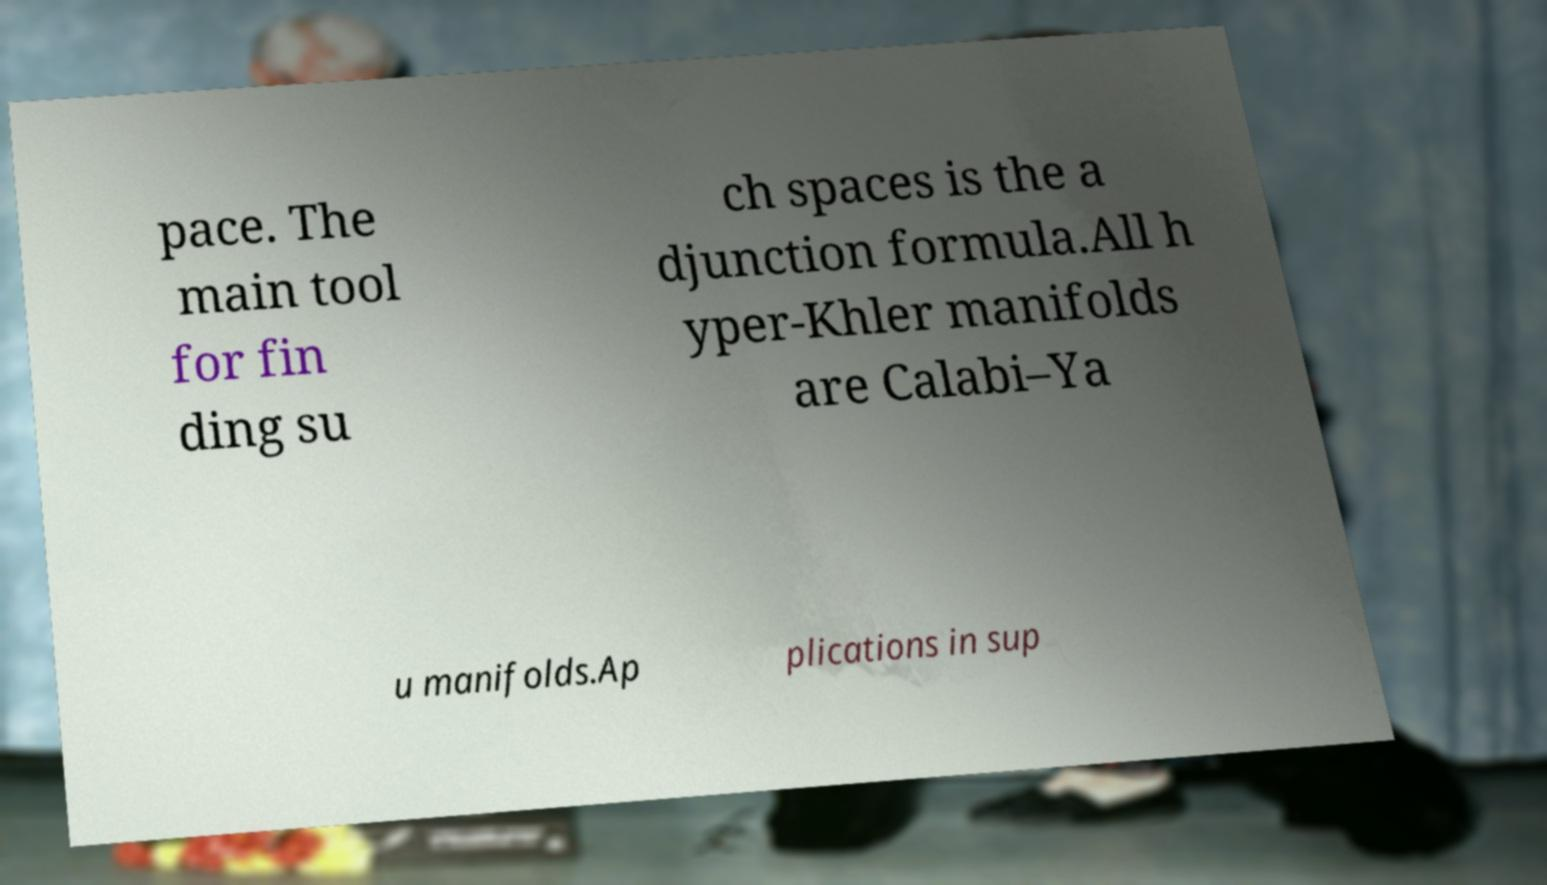For documentation purposes, I need the text within this image transcribed. Could you provide that? pace. The main tool for fin ding su ch spaces is the a djunction formula.All h yper-Khler manifolds are Calabi–Ya u manifolds.Ap plications in sup 